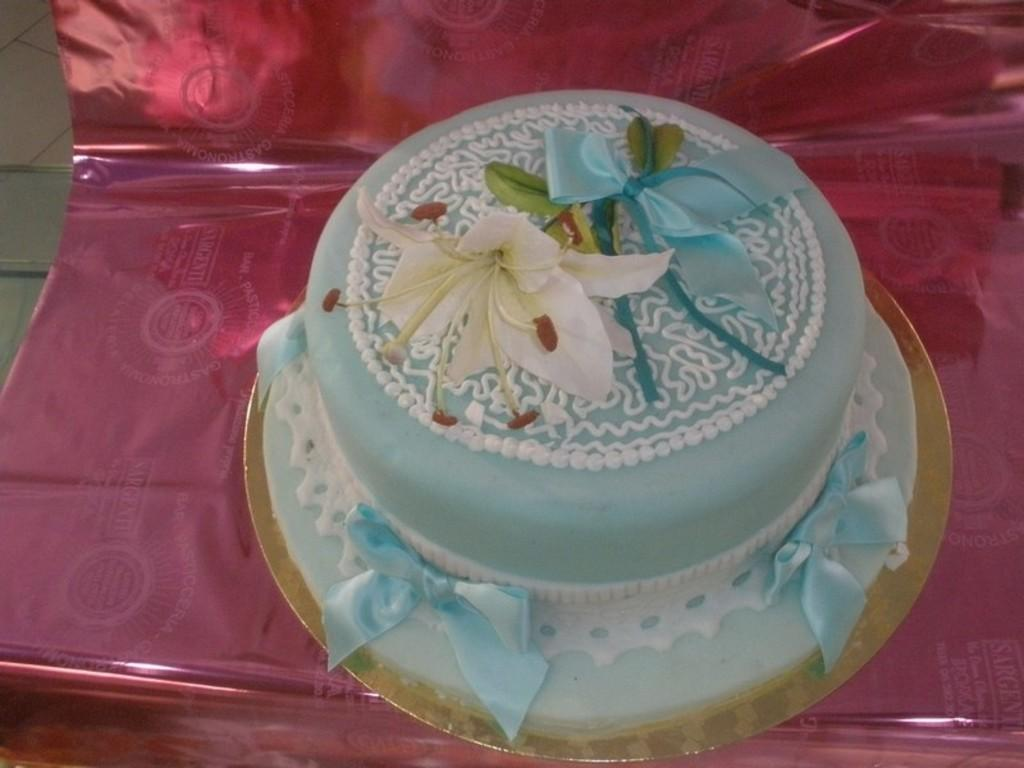What is the main subject of the image? There is a cake in the image. Can you describe any other objects or features in the image? There is an object that is pink in color in the image. How does the rain affect the cake in the image? There is no rain present in the image, so it cannot affect the cake. What is the height of the pocket in the image? There is no pocket present in the image, so its height cannot be determined. 